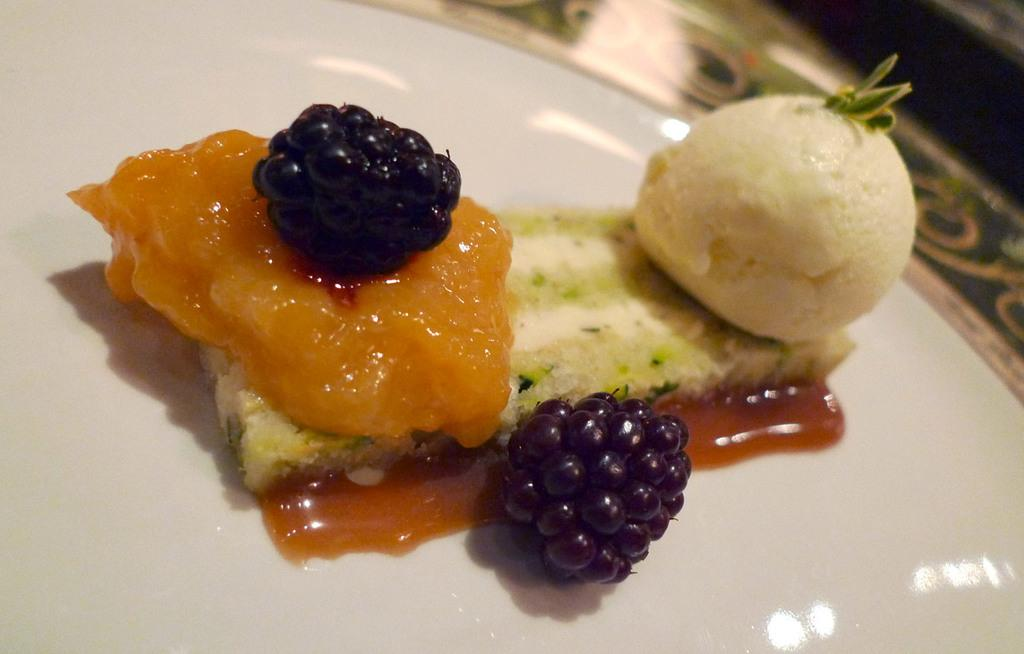What is on the plate that is visible in the image? There is food in a plate in the image. Can you describe the background of the image? The background of the image is blurred. What type of minute can be seen in the image? There are no minutes present in the image; it features food on a plate and a blurred background. 